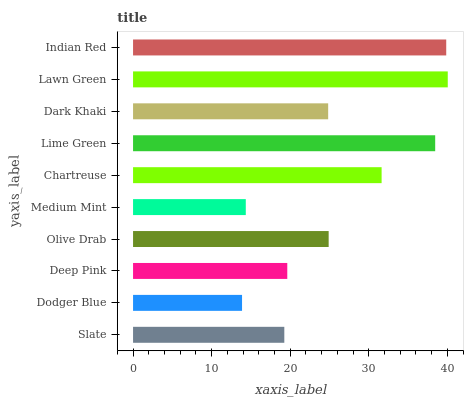Is Dodger Blue the minimum?
Answer yes or no. Yes. Is Lawn Green the maximum?
Answer yes or no. Yes. Is Deep Pink the minimum?
Answer yes or no. No. Is Deep Pink the maximum?
Answer yes or no. No. Is Deep Pink greater than Dodger Blue?
Answer yes or no. Yes. Is Dodger Blue less than Deep Pink?
Answer yes or no. Yes. Is Dodger Blue greater than Deep Pink?
Answer yes or no. No. Is Deep Pink less than Dodger Blue?
Answer yes or no. No. Is Olive Drab the high median?
Answer yes or no. Yes. Is Dark Khaki the low median?
Answer yes or no. Yes. Is Slate the high median?
Answer yes or no. No. Is Chartreuse the low median?
Answer yes or no. No. 